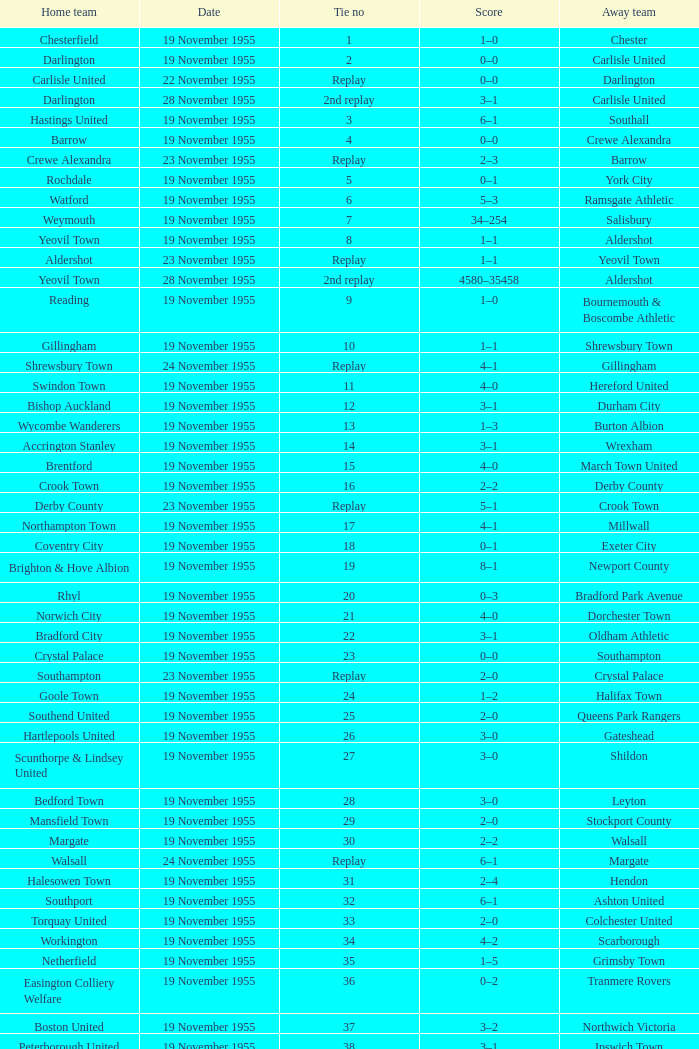What is the date of tie no. 34? 19 November 1955. 